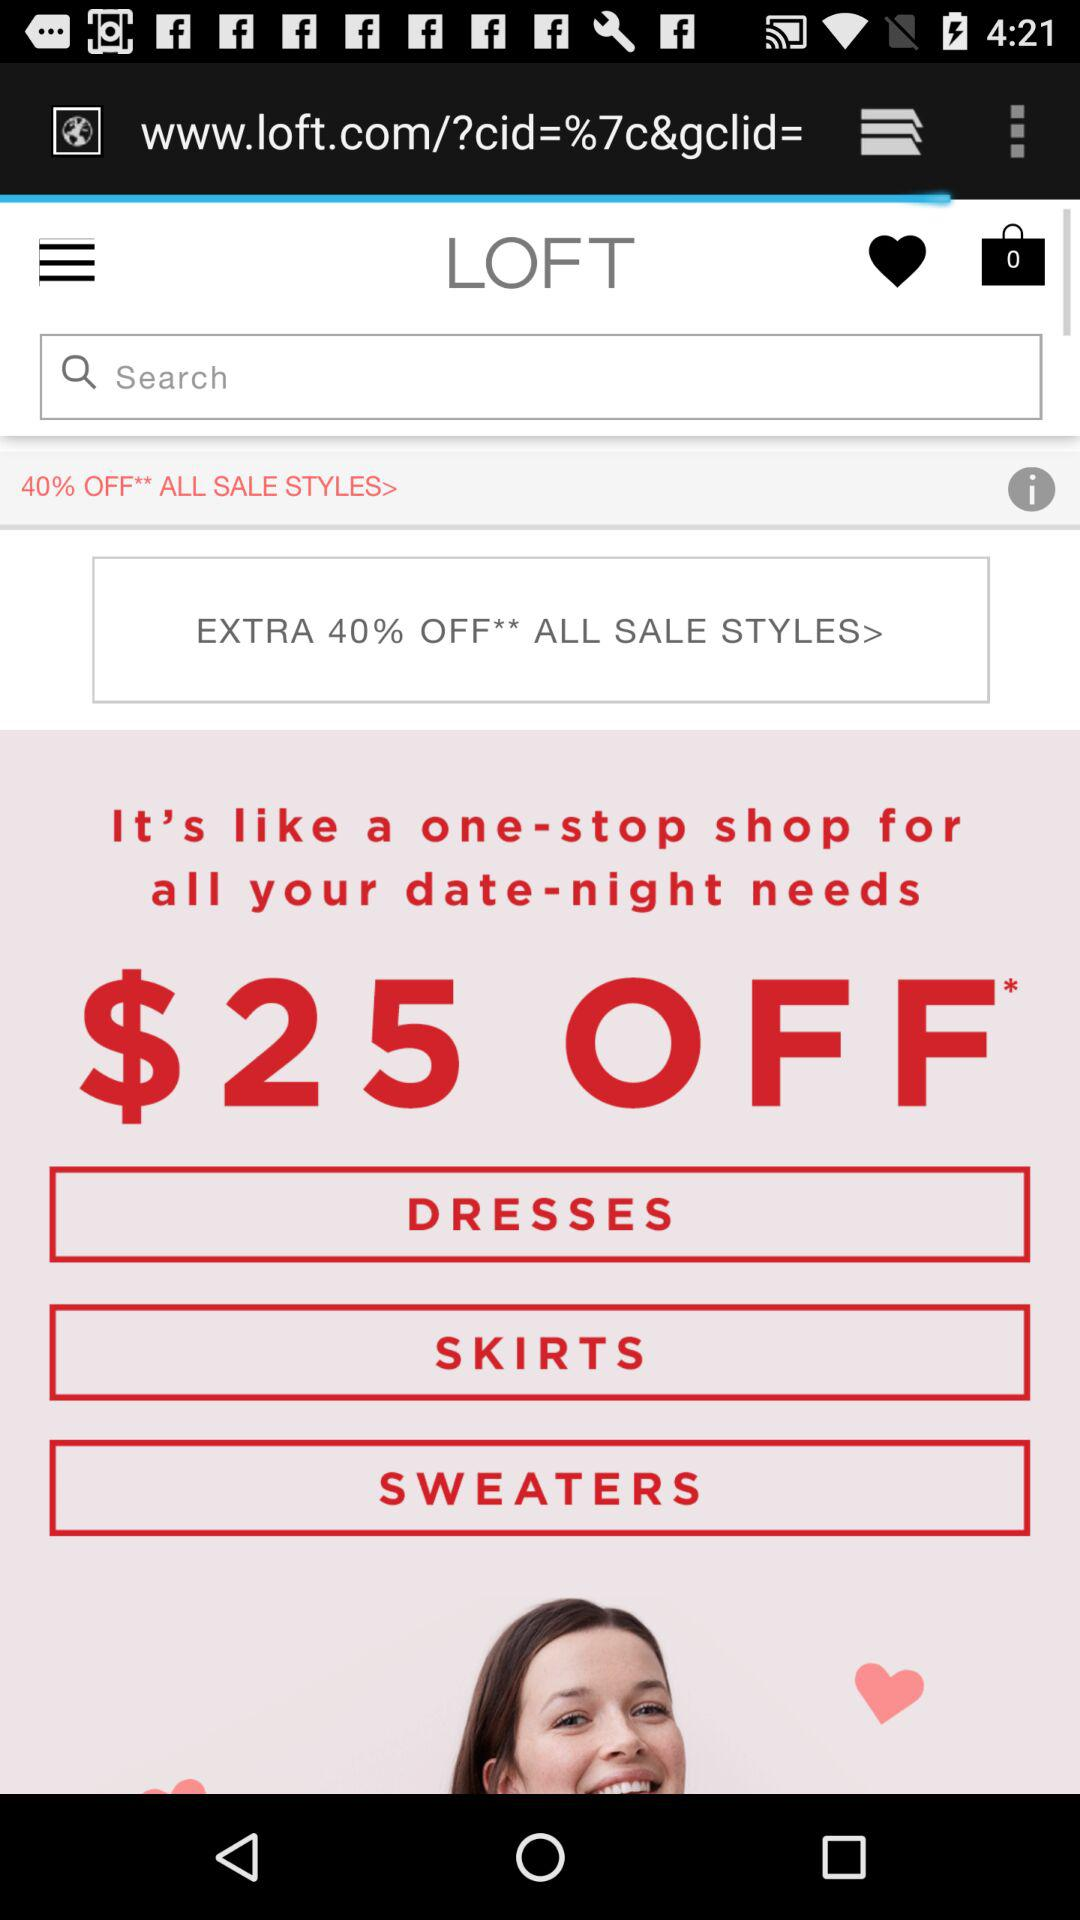How much extra percent off is there on all sale styles? There is an extra 40% off on all sale styles. 